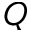Convert formula to latex. <formula><loc_0><loc_0><loc_500><loc_500>Q</formula> 